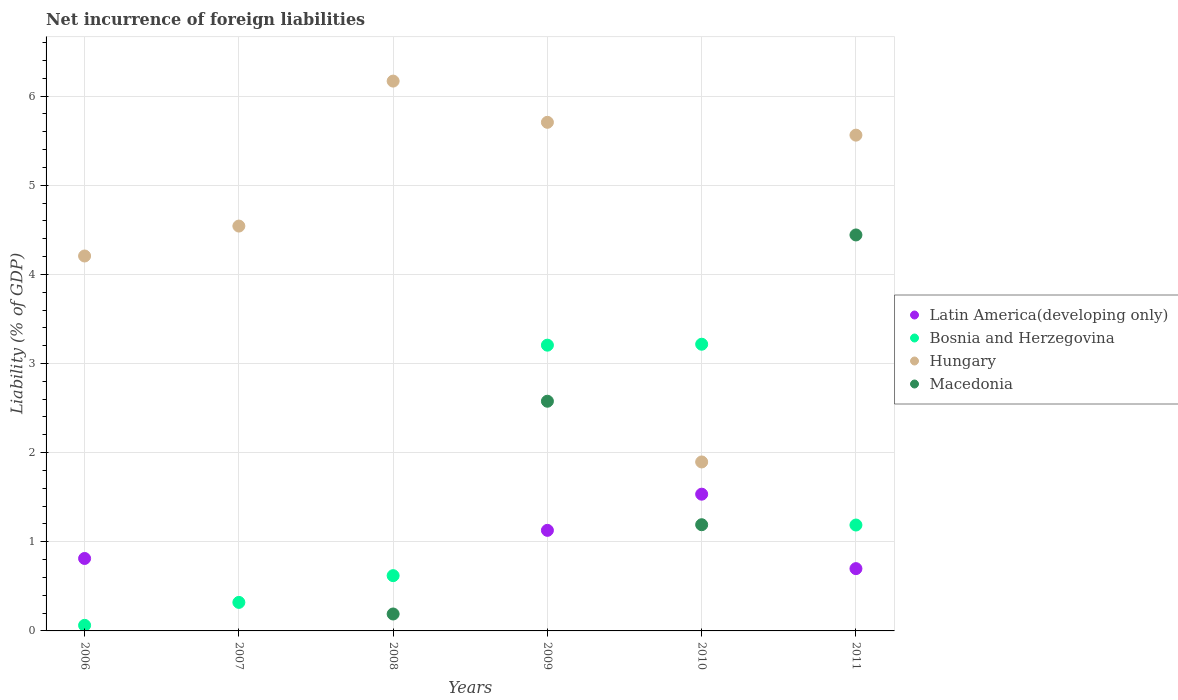How many different coloured dotlines are there?
Your answer should be compact. 4. What is the net incurrence of foreign liabilities in Bosnia and Herzegovina in 2006?
Keep it short and to the point. 0.06. Across all years, what is the maximum net incurrence of foreign liabilities in Macedonia?
Provide a succinct answer. 4.44. Across all years, what is the minimum net incurrence of foreign liabilities in Bosnia and Herzegovina?
Your answer should be very brief. 0.06. What is the total net incurrence of foreign liabilities in Macedonia in the graph?
Ensure brevity in your answer.  8.4. What is the difference between the net incurrence of foreign liabilities in Hungary in 2009 and that in 2011?
Provide a short and direct response. 0.14. What is the difference between the net incurrence of foreign liabilities in Bosnia and Herzegovina in 2011 and the net incurrence of foreign liabilities in Hungary in 2010?
Give a very brief answer. -0.71. What is the average net incurrence of foreign liabilities in Macedonia per year?
Your response must be concise. 1.4. In the year 2009, what is the difference between the net incurrence of foreign liabilities in Macedonia and net incurrence of foreign liabilities in Bosnia and Herzegovina?
Offer a terse response. -0.63. In how many years, is the net incurrence of foreign liabilities in Bosnia and Herzegovina greater than 5.6 %?
Your answer should be very brief. 0. Is the difference between the net incurrence of foreign liabilities in Macedonia in 2010 and 2011 greater than the difference between the net incurrence of foreign liabilities in Bosnia and Herzegovina in 2010 and 2011?
Your response must be concise. No. What is the difference between the highest and the second highest net incurrence of foreign liabilities in Bosnia and Herzegovina?
Offer a terse response. 0.01. What is the difference between the highest and the lowest net incurrence of foreign liabilities in Bosnia and Herzegovina?
Provide a short and direct response. 3.15. Is the sum of the net incurrence of foreign liabilities in Hungary in 2006 and 2007 greater than the maximum net incurrence of foreign liabilities in Macedonia across all years?
Make the answer very short. Yes. Is it the case that in every year, the sum of the net incurrence of foreign liabilities in Macedonia and net incurrence of foreign liabilities in Hungary  is greater than the sum of net incurrence of foreign liabilities in Bosnia and Herzegovina and net incurrence of foreign liabilities in Latin America(developing only)?
Keep it short and to the point. No. Does the net incurrence of foreign liabilities in Bosnia and Herzegovina monotonically increase over the years?
Provide a succinct answer. No. Is the net incurrence of foreign liabilities in Bosnia and Herzegovina strictly greater than the net incurrence of foreign liabilities in Latin America(developing only) over the years?
Give a very brief answer. No. How many dotlines are there?
Ensure brevity in your answer.  4. How many years are there in the graph?
Ensure brevity in your answer.  6. Does the graph contain grids?
Your response must be concise. Yes. Where does the legend appear in the graph?
Provide a short and direct response. Center right. How many legend labels are there?
Give a very brief answer. 4. How are the legend labels stacked?
Give a very brief answer. Vertical. What is the title of the graph?
Offer a very short reply. Net incurrence of foreign liabilities. What is the label or title of the Y-axis?
Provide a succinct answer. Liability (% of GDP). What is the Liability (% of GDP) in Latin America(developing only) in 2006?
Your answer should be very brief. 0.81. What is the Liability (% of GDP) of Bosnia and Herzegovina in 2006?
Offer a terse response. 0.06. What is the Liability (% of GDP) of Hungary in 2006?
Your answer should be very brief. 4.21. What is the Liability (% of GDP) of Latin America(developing only) in 2007?
Keep it short and to the point. 0. What is the Liability (% of GDP) of Bosnia and Herzegovina in 2007?
Make the answer very short. 0.32. What is the Liability (% of GDP) of Hungary in 2007?
Your answer should be very brief. 4.54. What is the Liability (% of GDP) in Latin America(developing only) in 2008?
Provide a succinct answer. 0. What is the Liability (% of GDP) of Bosnia and Herzegovina in 2008?
Provide a short and direct response. 0.62. What is the Liability (% of GDP) of Hungary in 2008?
Make the answer very short. 6.17. What is the Liability (% of GDP) in Macedonia in 2008?
Give a very brief answer. 0.19. What is the Liability (% of GDP) of Latin America(developing only) in 2009?
Provide a succinct answer. 1.13. What is the Liability (% of GDP) of Bosnia and Herzegovina in 2009?
Give a very brief answer. 3.21. What is the Liability (% of GDP) in Hungary in 2009?
Make the answer very short. 5.71. What is the Liability (% of GDP) of Macedonia in 2009?
Your answer should be compact. 2.58. What is the Liability (% of GDP) in Latin America(developing only) in 2010?
Offer a terse response. 1.53. What is the Liability (% of GDP) of Bosnia and Herzegovina in 2010?
Provide a short and direct response. 3.22. What is the Liability (% of GDP) in Hungary in 2010?
Your answer should be very brief. 1.9. What is the Liability (% of GDP) of Macedonia in 2010?
Your answer should be compact. 1.19. What is the Liability (% of GDP) in Latin America(developing only) in 2011?
Offer a terse response. 0.7. What is the Liability (% of GDP) in Bosnia and Herzegovina in 2011?
Keep it short and to the point. 1.19. What is the Liability (% of GDP) in Hungary in 2011?
Your answer should be very brief. 5.56. What is the Liability (% of GDP) of Macedonia in 2011?
Provide a short and direct response. 4.44. Across all years, what is the maximum Liability (% of GDP) in Latin America(developing only)?
Offer a very short reply. 1.53. Across all years, what is the maximum Liability (% of GDP) in Bosnia and Herzegovina?
Offer a terse response. 3.22. Across all years, what is the maximum Liability (% of GDP) of Hungary?
Offer a very short reply. 6.17. Across all years, what is the maximum Liability (% of GDP) of Macedonia?
Your answer should be compact. 4.44. Across all years, what is the minimum Liability (% of GDP) in Bosnia and Herzegovina?
Ensure brevity in your answer.  0.06. Across all years, what is the minimum Liability (% of GDP) of Hungary?
Offer a very short reply. 1.9. What is the total Liability (% of GDP) in Latin America(developing only) in the graph?
Give a very brief answer. 4.17. What is the total Liability (% of GDP) in Bosnia and Herzegovina in the graph?
Your response must be concise. 8.61. What is the total Liability (% of GDP) in Hungary in the graph?
Ensure brevity in your answer.  28.08. What is the total Liability (% of GDP) of Macedonia in the graph?
Provide a succinct answer. 8.4. What is the difference between the Liability (% of GDP) in Bosnia and Herzegovina in 2006 and that in 2007?
Make the answer very short. -0.26. What is the difference between the Liability (% of GDP) in Hungary in 2006 and that in 2007?
Give a very brief answer. -0.34. What is the difference between the Liability (% of GDP) in Bosnia and Herzegovina in 2006 and that in 2008?
Offer a terse response. -0.56. What is the difference between the Liability (% of GDP) in Hungary in 2006 and that in 2008?
Provide a short and direct response. -1.96. What is the difference between the Liability (% of GDP) in Latin America(developing only) in 2006 and that in 2009?
Your response must be concise. -0.32. What is the difference between the Liability (% of GDP) of Bosnia and Herzegovina in 2006 and that in 2009?
Offer a very short reply. -3.14. What is the difference between the Liability (% of GDP) in Hungary in 2006 and that in 2009?
Your response must be concise. -1.5. What is the difference between the Liability (% of GDP) of Latin America(developing only) in 2006 and that in 2010?
Make the answer very short. -0.72. What is the difference between the Liability (% of GDP) of Bosnia and Herzegovina in 2006 and that in 2010?
Offer a terse response. -3.15. What is the difference between the Liability (% of GDP) in Hungary in 2006 and that in 2010?
Provide a succinct answer. 2.31. What is the difference between the Liability (% of GDP) in Latin America(developing only) in 2006 and that in 2011?
Your response must be concise. 0.11. What is the difference between the Liability (% of GDP) of Bosnia and Herzegovina in 2006 and that in 2011?
Keep it short and to the point. -1.13. What is the difference between the Liability (% of GDP) in Hungary in 2006 and that in 2011?
Keep it short and to the point. -1.36. What is the difference between the Liability (% of GDP) in Bosnia and Herzegovina in 2007 and that in 2008?
Your answer should be very brief. -0.3. What is the difference between the Liability (% of GDP) in Hungary in 2007 and that in 2008?
Make the answer very short. -1.63. What is the difference between the Liability (% of GDP) in Bosnia and Herzegovina in 2007 and that in 2009?
Your answer should be compact. -2.89. What is the difference between the Liability (% of GDP) in Hungary in 2007 and that in 2009?
Your response must be concise. -1.16. What is the difference between the Liability (% of GDP) in Bosnia and Herzegovina in 2007 and that in 2010?
Keep it short and to the point. -2.9. What is the difference between the Liability (% of GDP) of Hungary in 2007 and that in 2010?
Ensure brevity in your answer.  2.65. What is the difference between the Liability (% of GDP) of Bosnia and Herzegovina in 2007 and that in 2011?
Provide a short and direct response. -0.87. What is the difference between the Liability (% of GDP) in Hungary in 2007 and that in 2011?
Offer a very short reply. -1.02. What is the difference between the Liability (% of GDP) in Bosnia and Herzegovina in 2008 and that in 2009?
Make the answer very short. -2.59. What is the difference between the Liability (% of GDP) in Hungary in 2008 and that in 2009?
Offer a terse response. 0.46. What is the difference between the Liability (% of GDP) in Macedonia in 2008 and that in 2009?
Make the answer very short. -2.39. What is the difference between the Liability (% of GDP) in Bosnia and Herzegovina in 2008 and that in 2010?
Make the answer very short. -2.6. What is the difference between the Liability (% of GDP) of Hungary in 2008 and that in 2010?
Offer a very short reply. 4.27. What is the difference between the Liability (% of GDP) of Macedonia in 2008 and that in 2010?
Keep it short and to the point. -1. What is the difference between the Liability (% of GDP) in Bosnia and Herzegovina in 2008 and that in 2011?
Give a very brief answer. -0.57. What is the difference between the Liability (% of GDP) of Hungary in 2008 and that in 2011?
Ensure brevity in your answer.  0.61. What is the difference between the Liability (% of GDP) of Macedonia in 2008 and that in 2011?
Your response must be concise. -4.25. What is the difference between the Liability (% of GDP) of Latin America(developing only) in 2009 and that in 2010?
Ensure brevity in your answer.  -0.41. What is the difference between the Liability (% of GDP) in Bosnia and Herzegovina in 2009 and that in 2010?
Offer a terse response. -0.01. What is the difference between the Liability (% of GDP) of Hungary in 2009 and that in 2010?
Your answer should be compact. 3.81. What is the difference between the Liability (% of GDP) of Macedonia in 2009 and that in 2010?
Make the answer very short. 1.39. What is the difference between the Liability (% of GDP) in Latin America(developing only) in 2009 and that in 2011?
Your answer should be very brief. 0.43. What is the difference between the Liability (% of GDP) of Bosnia and Herzegovina in 2009 and that in 2011?
Your answer should be very brief. 2.02. What is the difference between the Liability (% of GDP) in Hungary in 2009 and that in 2011?
Provide a succinct answer. 0.14. What is the difference between the Liability (% of GDP) in Macedonia in 2009 and that in 2011?
Keep it short and to the point. -1.87. What is the difference between the Liability (% of GDP) in Latin America(developing only) in 2010 and that in 2011?
Your answer should be very brief. 0.84. What is the difference between the Liability (% of GDP) in Bosnia and Herzegovina in 2010 and that in 2011?
Offer a terse response. 2.03. What is the difference between the Liability (% of GDP) in Hungary in 2010 and that in 2011?
Provide a succinct answer. -3.67. What is the difference between the Liability (% of GDP) of Macedonia in 2010 and that in 2011?
Offer a very short reply. -3.25. What is the difference between the Liability (% of GDP) of Latin America(developing only) in 2006 and the Liability (% of GDP) of Bosnia and Herzegovina in 2007?
Provide a short and direct response. 0.49. What is the difference between the Liability (% of GDP) of Latin America(developing only) in 2006 and the Liability (% of GDP) of Hungary in 2007?
Keep it short and to the point. -3.73. What is the difference between the Liability (% of GDP) of Bosnia and Herzegovina in 2006 and the Liability (% of GDP) of Hungary in 2007?
Give a very brief answer. -4.48. What is the difference between the Liability (% of GDP) of Latin America(developing only) in 2006 and the Liability (% of GDP) of Bosnia and Herzegovina in 2008?
Ensure brevity in your answer.  0.19. What is the difference between the Liability (% of GDP) in Latin America(developing only) in 2006 and the Liability (% of GDP) in Hungary in 2008?
Your answer should be compact. -5.36. What is the difference between the Liability (% of GDP) in Latin America(developing only) in 2006 and the Liability (% of GDP) in Macedonia in 2008?
Offer a very short reply. 0.62. What is the difference between the Liability (% of GDP) in Bosnia and Herzegovina in 2006 and the Liability (% of GDP) in Hungary in 2008?
Your answer should be very brief. -6.11. What is the difference between the Liability (% of GDP) of Bosnia and Herzegovina in 2006 and the Liability (% of GDP) of Macedonia in 2008?
Provide a succinct answer. -0.13. What is the difference between the Liability (% of GDP) of Hungary in 2006 and the Liability (% of GDP) of Macedonia in 2008?
Provide a succinct answer. 4.02. What is the difference between the Liability (% of GDP) of Latin America(developing only) in 2006 and the Liability (% of GDP) of Bosnia and Herzegovina in 2009?
Provide a short and direct response. -2.39. What is the difference between the Liability (% of GDP) in Latin America(developing only) in 2006 and the Liability (% of GDP) in Hungary in 2009?
Offer a terse response. -4.89. What is the difference between the Liability (% of GDP) in Latin America(developing only) in 2006 and the Liability (% of GDP) in Macedonia in 2009?
Give a very brief answer. -1.76. What is the difference between the Liability (% of GDP) of Bosnia and Herzegovina in 2006 and the Liability (% of GDP) of Hungary in 2009?
Offer a terse response. -5.64. What is the difference between the Liability (% of GDP) of Bosnia and Herzegovina in 2006 and the Liability (% of GDP) of Macedonia in 2009?
Offer a very short reply. -2.51. What is the difference between the Liability (% of GDP) of Hungary in 2006 and the Liability (% of GDP) of Macedonia in 2009?
Offer a terse response. 1.63. What is the difference between the Liability (% of GDP) of Latin America(developing only) in 2006 and the Liability (% of GDP) of Bosnia and Herzegovina in 2010?
Provide a succinct answer. -2.4. What is the difference between the Liability (% of GDP) in Latin America(developing only) in 2006 and the Liability (% of GDP) in Hungary in 2010?
Your response must be concise. -1.08. What is the difference between the Liability (% of GDP) in Latin America(developing only) in 2006 and the Liability (% of GDP) in Macedonia in 2010?
Ensure brevity in your answer.  -0.38. What is the difference between the Liability (% of GDP) of Bosnia and Herzegovina in 2006 and the Liability (% of GDP) of Hungary in 2010?
Provide a short and direct response. -1.83. What is the difference between the Liability (% of GDP) in Bosnia and Herzegovina in 2006 and the Liability (% of GDP) in Macedonia in 2010?
Provide a short and direct response. -1.13. What is the difference between the Liability (% of GDP) in Hungary in 2006 and the Liability (% of GDP) in Macedonia in 2010?
Your answer should be compact. 3.01. What is the difference between the Liability (% of GDP) in Latin America(developing only) in 2006 and the Liability (% of GDP) in Bosnia and Herzegovina in 2011?
Offer a very short reply. -0.38. What is the difference between the Liability (% of GDP) in Latin America(developing only) in 2006 and the Liability (% of GDP) in Hungary in 2011?
Your answer should be compact. -4.75. What is the difference between the Liability (% of GDP) of Latin America(developing only) in 2006 and the Liability (% of GDP) of Macedonia in 2011?
Your response must be concise. -3.63. What is the difference between the Liability (% of GDP) in Bosnia and Herzegovina in 2006 and the Liability (% of GDP) in Hungary in 2011?
Provide a succinct answer. -5.5. What is the difference between the Liability (% of GDP) in Bosnia and Herzegovina in 2006 and the Liability (% of GDP) in Macedonia in 2011?
Provide a short and direct response. -4.38. What is the difference between the Liability (% of GDP) in Hungary in 2006 and the Liability (% of GDP) in Macedonia in 2011?
Your answer should be very brief. -0.24. What is the difference between the Liability (% of GDP) of Bosnia and Herzegovina in 2007 and the Liability (% of GDP) of Hungary in 2008?
Keep it short and to the point. -5.85. What is the difference between the Liability (% of GDP) in Bosnia and Herzegovina in 2007 and the Liability (% of GDP) in Macedonia in 2008?
Your answer should be very brief. 0.13. What is the difference between the Liability (% of GDP) of Hungary in 2007 and the Liability (% of GDP) of Macedonia in 2008?
Keep it short and to the point. 4.35. What is the difference between the Liability (% of GDP) in Bosnia and Herzegovina in 2007 and the Liability (% of GDP) in Hungary in 2009?
Ensure brevity in your answer.  -5.39. What is the difference between the Liability (% of GDP) of Bosnia and Herzegovina in 2007 and the Liability (% of GDP) of Macedonia in 2009?
Provide a short and direct response. -2.26. What is the difference between the Liability (% of GDP) of Hungary in 2007 and the Liability (% of GDP) of Macedonia in 2009?
Provide a short and direct response. 1.97. What is the difference between the Liability (% of GDP) of Bosnia and Herzegovina in 2007 and the Liability (% of GDP) of Hungary in 2010?
Ensure brevity in your answer.  -1.58. What is the difference between the Liability (% of GDP) of Bosnia and Herzegovina in 2007 and the Liability (% of GDP) of Macedonia in 2010?
Keep it short and to the point. -0.87. What is the difference between the Liability (% of GDP) of Hungary in 2007 and the Liability (% of GDP) of Macedonia in 2010?
Make the answer very short. 3.35. What is the difference between the Liability (% of GDP) in Bosnia and Herzegovina in 2007 and the Liability (% of GDP) in Hungary in 2011?
Provide a succinct answer. -5.24. What is the difference between the Liability (% of GDP) of Bosnia and Herzegovina in 2007 and the Liability (% of GDP) of Macedonia in 2011?
Keep it short and to the point. -4.12. What is the difference between the Liability (% of GDP) in Hungary in 2007 and the Liability (% of GDP) in Macedonia in 2011?
Ensure brevity in your answer.  0.1. What is the difference between the Liability (% of GDP) of Bosnia and Herzegovina in 2008 and the Liability (% of GDP) of Hungary in 2009?
Ensure brevity in your answer.  -5.09. What is the difference between the Liability (% of GDP) in Bosnia and Herzegovina in 2008 and the Liability (% of GDP) in Macedonia in 2009?
Your response must be concise. -1.96. What is the difference between the Liability (% of GDP) in Hungary in 2008 and the Liability (% of GDP) in Macedonia in 2009?
Ensure brevity in your answer.  3.59. What is the difference between the Liability (% of GDP) of Bosnia and Herzegovina in 2008 and the Liability (% of GDP) of Hungary in 2010?
Offer a terse response. -1.28. What is the difference between the Liability (% of GDP) of Bosnia and Herzegovina in 2008 and the Liability (% of GDP) of Macedonia in 2010?
Your answer should be very brief. -0.57. What is the difference between the Liability (% of GDP) in Hungary in 2008 and the Liability (% of GDP) in Macedonia in 2010?
Keep it short and to the point. 4.98. What is the difference between the Liability (% of GDP) in Bosnia and Herzegovina in 2008 and the Liability (% of GDP) in Hungary in 2011?
Your answer should be compact. -4.94. What is the difference between the Liability (% of GDP) in Bosnia and Herzegovina in 2008 and the Liability (% of GDP) in Macedonia in 2011?
Provide a succinct answer. -3.82. What is the difference between the Liability (% of GDP) in Hungary in 2008 and the Liability (% of GDP) in Macedonia in 2011?
Your answer should be compact. 1.73. What is the difference between the Liability (% of GDP) in Latin America(developing only) in 2009 and the Liability (% of GDP) in Bosnia and Herzegovina in 2010?
Your response must be concise. -2.09. What is the difference between the Liability (% of GDP) of Latin America(developing only) in 2009 and the Liability (% of GDP) of Hungary in 2010?
Provide a short and direct response. -0.77. What is the difference between the Liability (% of GDP) in Latin America(developing only) in 2009 and the Liability (% of GDP) in Macedonia in 2010?
Your answer should be compact. -0.06. What is the difference between the Liability (% of GDP) in Bosnia and Herzegovina in 2009 and the Liability (% of GDP) in Hungary in 2010?
Your response must be concise. 1.31. What is the difference between the Liability (% of GDP) of Bosnia and Herzegovina in 2009 and the Liability (% of GDP) of Macedonia in 2010?
Provide a short and direct response. 2.01. What is the difference between the Liability (% of GDP) in Hungary in 2009 and the Liability (% of GDP) in Macedonia in 2010?
Your answer should be very brief. 4.51. What is the difference between the Liability (% of GDP) of Latin America(developing only) in 2009 and the Liability (% of GDP) of Bosnia and Herzegovina in 2011?
Keep it short and to the point. -0.06. What is the difference between the Liability (% of GDP) in Latin America(developing only) in 2009 and the Liability (% of GDP) in Hungary in 2011?
Provide a short and direct response. -4.43. What is the difference between the Liability (% of GDP) of Latin America(developing only) in 2009 and the Liability (% of GDP) of Macedonia in 2011?
Offer a terse response. -3.31. What is the difference between the Liability (% of GDP) of Bosnia and Herzegovina in 2009 and the Liability (% of GDP) of Hungary in 2011?
Provide a short and direct response. -2.36. What is the difference between the Liability (% of GDP) of Bosnia and Herzegovina in 2009 and the Liability (% of GDP) of Macedonia in 2011?
Offer a terse response. -1.24. What is the difference between the Liability (% of GDP) of Hungary in 2009 and the Liability (% of GDP) of Macedonia in 2011?
Provide a succinct answer. 1.26. What is the difference between the Liability (% of GDP) of Latin America(developing only) in 2010 and the Liability (% of GDP) of Bosnia and Herzegovina in 2011?
Ensure brevity in your answer.  0.35. What is the difference between the Liability (% of GDP) of Latin America(developing only) in 2010 and the Liability (% of GDP) of Hungary in 2011?
Your answer should be compact. -4.03. What is the difference between the Liability (% of GDP) in Latin America(developing only) in 2010 and the Liability (% of GDP) in Macedonia in 2011?
Offer a terse response. -2.91. What is the difference between the Liability (% of GDP) in Bosnia and Herzegovina in 2010 and the Liability (% of GDP) in Hungary in 2011?
Give a very brief answer. -2.35. What is the difference between the Liability (% of GDP) of Bosnia and Herzegovina in 2010 and the Liability (% of GDP) of Macedonia in 2011?
Your answer should be compact. -1.23. What is the difference between the Liability (% of GDP) of Hungary in 2010 and the Liability (% of GDP) of Macedonia in 2011?
Make the answer very short. -2.55. What is the average Liability (% of GDP) of Latin America(developing only) per year?
Provide a short and direct response. 0.7. What is the average Liability (% of GDP) in Bosnia and Herzegovina per year?
Provide a succinct answer. 1.44. What is the average Liability (% of GDP) in Hungary per year?
Offer a terse response. 4.68. What is the average Liability (% of GDP) in Macedonia per year?
Make the answer very short. 1.4. In the year 2006, what is the difference between the Liability (% of GDP) in Latin America(developing only) and Liability (% of GDP) in Bosnia and Herzegovina?
Provide a succinct answer. 0.75. In the year 2006, what is the difference between the Liability (% of GDP) in Latin America(developing only) and Liability (% of GDP) in Hungary?
Provide a short and direct response. -3.39. In the year 2006, what is the difference between the Liability (% of GDP) in Bosnia and Herzegovina and Liability (% of GDP) in Hungary?
Keep it short and to the point. -4.14. In the year 2007, what is the difference between the Liability (% of GDP) of Bosnia and Herzegovina and Liability (% of GDP) of Hungary?
Make the answer very short. -4.22. In the year 2008, what is the difference between the Liability (% of GDP) in Bosnia and Herzegovina and Liability (% of GDP) in Hungary?
Your answer should be compact. -5.55. In the year 2008, what is the difference between the Liability (% of GDP) in Bosnia and Herzegovina and Liability (% of GDP) in Macedonia?
Make the answer very short. 0.43. In the year 2008, what is the difference between the Liability (% of GDP) of Hungary and Liability (% of GDP) of Macedonia?
Your answer should be compact. 5.98. In the year 2009, what is the difference between the Liability (% of GDP) in Latin America(developing only) and Liability (% of GDP) in Bosnia and Herzegovina?
Provide a succinct answer. -2.08. In the year 2009, what is the difference between the Liability (% of GDP) of Latin America(developing only) and Liability (% of GDP) of Hungary?
Your answer should be very brief. -4.58. In the year 2009, what is the difference between the Liability (% of GDP) of Latin America(developing only) and Liability (% of GDP) of Macedonia?
Make the answer very short. -1.45. In the year 2009, what is the difference between the Liability (% of GDP) in Bosnia and Herzegovina and Liability (% of GDP) in Hungary?
Your response must be concise. -2.5. In the year 2009, what is the difference between the Liability (% of GDP) of Bosnia and Herzegovina and Liability (% of GDP) of Macedonia?
Make the answer very short. 0.63. In the year 2009, what is the difference between the Liability (% of GDP) in Hungary and Liability (% of GDP) in Macedonia?
Give a very brief answer. 3.13. In the year 2010, what is the difference between the Liability (% of GDP) of Latin America(developing only) and Liability (% of GDP) of Bosnia and Herzegovina?
Your answer should be very brief. -1.68. In the year 2010, what is the difference between the Liability (% of GDP) in Latin America(developing only) and Liability (% of GDP) in Hungary?
Make the answer very short. -0.36. In the year 2010, what is the difference between the Liability (% of GDP) of Latin America(developing only) and Liability (% of GDP) of Macedonia?
Provide a short and direct response. 0.34. In the year 2010, what is the difference between the Liability (% of GDP) of Bosnia and Herzegovina and Liability (% of GDP) of Hungary?
Offer a very short reply. 1.32. In the year 2010, what is the difference between the Liability (% of GDP) in Bosnia and Herzegovina and Liability (% of GDP) in Macedonia?
Offer a terse response. 2.02. In the year 2010, what is the difference between the Liability (% of GDP) in Hungary and Liability (% of GDP) in Macedonia?
Provide a succinct answer. 0.7. In the year 2011, what is the difference between the Liability (% of GDP) in Latin America(developing only) and Liability (% of GDP) in Bosnia and Herzegovina?
Ensure brevity in your answer.  -0.49. In the year 2011, what is the difference between the Liability (% of GDP) of Latin America(developing only) and Liability (% of GDP) of Hungary?
Your answer should be very brief. -4.86. In the year 2011, what is the difference between the Liability (% of GDP) of Latin America(developing only) and Liability (% of GDP) of Macedonia?
Your answer should be very brief. -3.74. In the year 2011, what is the difference between the Liability (% of GDP) in Bosnia and Herzegovina and Liability (% of GDP) in Hungary?
Give a very brief answer. -4.37. In the year 2011, what is the difference between the Liability (% of GDP) in Bosnia and Herzegovina and Liability (% of GDP) in Macedonia?
Make the answer very short. -3.25. In the year 2011, what is the difference between the Liability (% of GDP) of Hungary and Liability (% of GDP) of Macedonia?
Keep it short and to the point. 1.12. What is the ratio of the Liability (% of GDP) in Bosnia and Herzegovina in 2006 to that in 2007?
Offer a terse response. 0.2. What is the ratio of the Liability (% of GDP) of Hungary in 2006 to that in 2007?
Make the answer very short. 0.93. What is the ratio of the Liability (% of GDP) in Bosnia and Herzegovina in 2006 to that in 2008?
Ensure brevity in your answer.  0.1. What is the ratio of the Liability (% of GDP) in Hungary in 2006 to that in 2008?
Keep it short and to the point. 0.68. What is the ratio of the Liability (% of GDP) in Latin America(developing only) in 2006 to that in 2009?
Your answer should be compact. 0.72. What is the ratio of the Liability (% of GDP) in Bosnia and Herzegovina in 2006 to that in 2009?
Your response must be concise. 0.02. What is the ratio of the Liability (% of GDP) of Hungary in 2006 to that in 2009?
Offer a very short reply. 0.74. What is the ratio of the Liability (% of GDP) of Latin America(developing only) in 2006 to that in 2010?
Provide a succinct answer. 0.53. What is the ratio of the Liability (% of GDP) in Bosnia and Herzegovina in 2006 to that in 2010?
Your answer should be very brief. 0.02. What is the ratio of the Liability (% of GDP) in Hungary in 2006 to that in 2010?
Your response must be concise. 2.22. What is the ratio of the Liability (% of GDP) of Latin America(developing only) in 2006 to that in 2011?
Provide a succinct answer. 1.16. What is the ratio of the Liability (% of GDP) of Bosnia and Herzegovina in 2006 to that in 2011?
Ensure brevity in your answer.  0.05. What is the ratio of the Liability (% of GDP) of Hungary in 2006 to that in 2011?
Provide a succinct answer. 0.76. What is the ratio of the Liability (% of GDP) of Bosnia and Herzegovina in 2007 to that in 2008?
Offer a terse response. 0.52. What is the ratio of the Liability (% of GDP) of Hungary in 2007 to that in 2008?
Your response must be concise. 0.74. What is the ratio of the Liability (% of GDP) of Bosnia and Herzegovina in 2007 to that in 2009?
Your answer should be very brief. 0.1. What is the ratio of the Liability (% of GDP) of Hungary in 2007 to that in 2009?
Ensure brevity in your answer.  0.8. What is the ratio of the Liability (% of GDP) of Bosnia and Herzegovina in 2007 to that in 2010?
Offer a terse response. 0.1. What is the ratio of the Liability (% of GDP) of Hungary in 2007 to that in 2010?
Your answer should be very brief. 2.4. What is the ratio of the Liability (% of GDP) in Bosnia and Herzegovina in 2007 to that in 2011?
Your answer should be compact. 0.27. What is the ratio of the Liability (% of GDP) in Hungary in 2007 to that in 2011?
Your answer should be compact. 0.82. What is the ratio of the Liability (% of GDP) in Bosnia and Herzegovina in 2008 to that in 2009?
Keep it short and to the point. 0.19. What is the ratio of the Liability (% of GDP) in Hungary in 2008 to that in 2009?
Your answer should be very brief. 1.08. What is the ratio of the Liability (% of GDP) of Macedonia in 2008 to that in 2009?
Provide a short and direct response. 0.07. What is the ratio of the Liability (% of GDP) in Bosnia and Herzegovina in 2008 to that in 2010?
Ensure brevity in your answer.  0.19. What is the ratio of the Liability (% of GDP) in Hungary in 2008 to that in 2010?
Your response must be concise. 3.25. What is the ratio of the Liability (% of GDP) of Macedonia in 2008 to that in 2010?
Provide a succinct answer. 0.16. What is the ratio of the Liability (% of GDP) of Bosnia and Herzegovina in 2008 to that in 2011?
Make the answer very short. 0.52. What is the ratio of the Liability (% of GDP) in Hungary in 2008 to that in 2011?
Ensure brevity in your answer.  1.11. What is the ratio of the Liability (% of GDP) of Macedonia in 2008 to that in 2011?
Provide a short and direct response. 0.04. What is the ratio of the Liability (% of GDP) of Latin America(developing only) in 2009 to that in 2010?
Give a very brief answer. 0.74. What is the ratio of the Liability (% of GDP) in Bosnia and Herzegovina in 2009 to that in 2010?
Offer a terse response. 1. What is the ratio of the Liability (% of GDP) of Hungary in 2009 to that in 2010?
Your response must be concise. 3.01. What is the ratio of the Liability (% of GDP) in Macedonia in 2009 to that in 2010?
Provide a short and direct response. 2.16. What is the ratio of the Liability (% of GDP) of Latin America(developing only) in 2009 to that in 2011?
Your answer should be very brief. 1.61. What is the ratio of the Liability (% of GDP) of Bosnia and Herzegovina in 2009 to that in 2011?
Provide a short and direct response. 2.7. What is the ratio of the Liability (% of GDP) in Hungary in 2009 to that in 2011?
Make the answer very short. 1.03. What is the ratio of the Liability (% of GDP) in Macedonia in 2009 to that in 2011?
Ensure brevity in your answer.  0.58. What is the ratio of the Liability (% of GDP) of Latin America(developing only) in 2010 to that in 2011?
Ensure brevity in your answer.  2.2. What is the ratio of the Liability (% of GDP) in Bosnia and Herzegovina in 2010 to that in 2011?
Your answer should be compact. 2.71. What is the ratio of the Liability (% of GDP) in Hungary in 2010 to that in 2011?
Ensure brevity in your answer.  0.34. What is the ratio of the Liability (% of GDP) in Macedonia in 2010 to that in 2011?
Provide a succinct answer. 0.27. What is the difference between the highest and the second highest Liability (% of GDP) of Latin America(developing only)?
Your answer should be very brief. 0.41. What is the difference between the highest and the second highest Liability (% of GDP) in Bosnia and Herzegovina?
Ensure brevity in your answer.  0.01. What is the difference between the highest and the second highest Liability (% of GDP) in Hungary?
Offer a very short reply. 0.46. What is the difference between the highest and the second highest Liability (% of GDP) of Macedonia?
Ensure brevity in your answer.  1.87. What is the difference between the highest and the lowest Liability (% of GDP) in Latin America(developing only)?
Your response must be concise. 1.53. What is the difference between the highest and the lowest Liability (% of GDP) of Bosnia and Herzegovina?
Your answer should be very brief. 3.15. What is the difference between the highest and the lowest Liability (% of GDP) in Hungary?
Your response must be concise. 4.27. What is the difference between the highest and the lowest Liability (% of GDP) in Macedonia?
Your response must be concise. 4.44. 